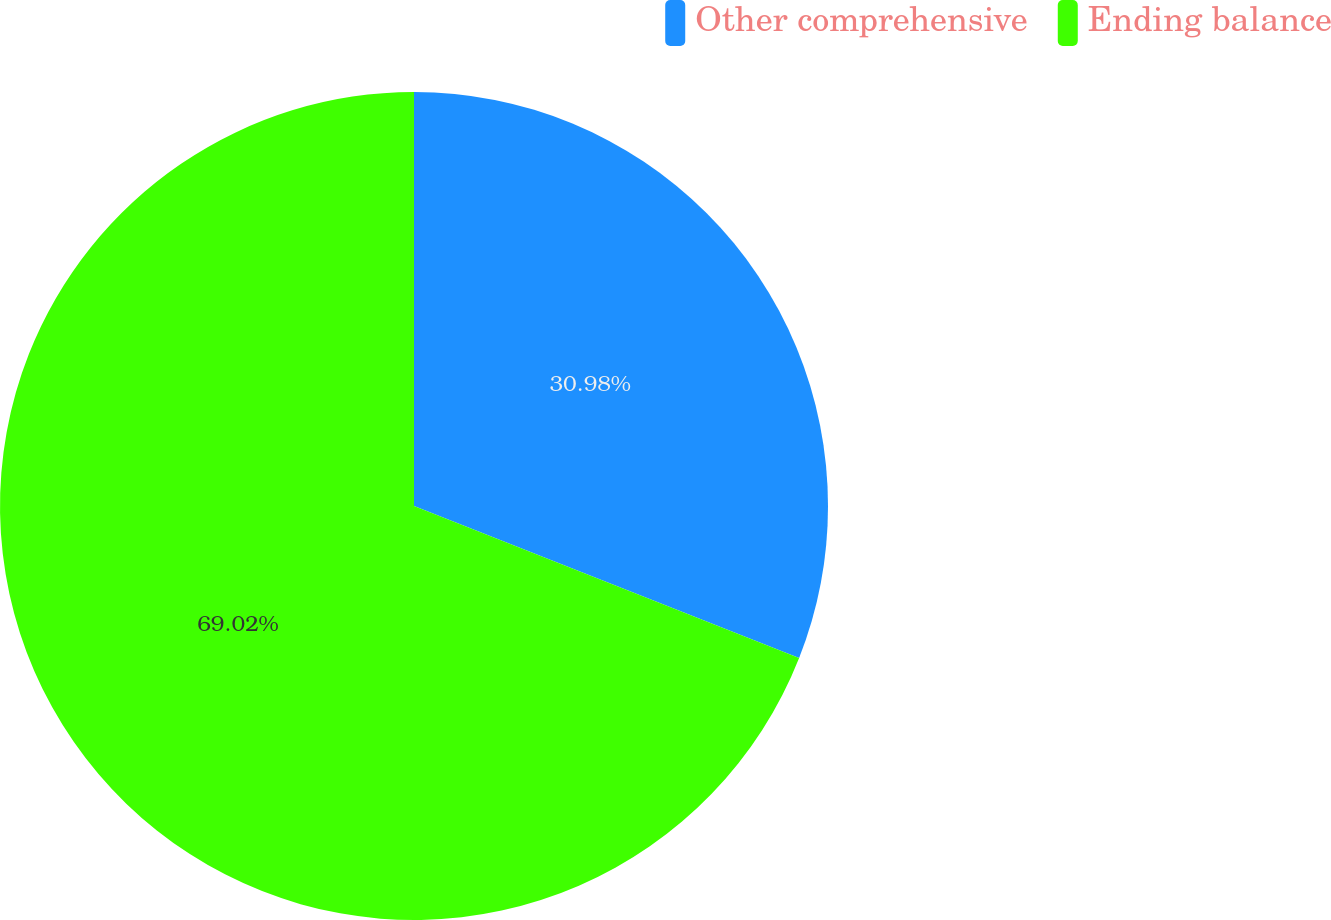<chart> <loc_0><loc_0><loc_500><loc_500><pie_chart><fcel>Other comprehensive<fcel>Ending balance<nl><fcel>30.98%<fcel>69.02%<nl></chart> 